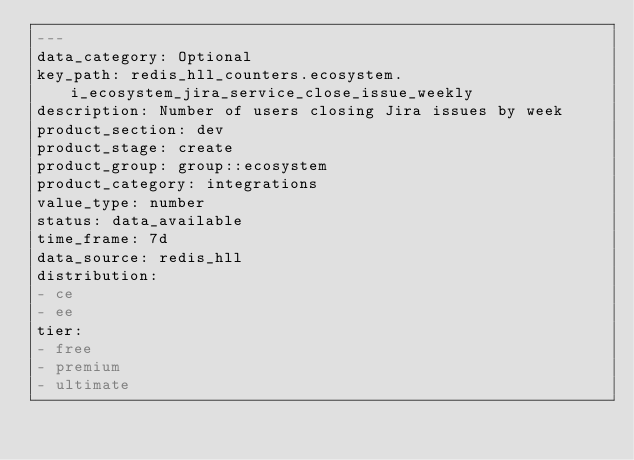<code> <loc_0><loc_0><loc_500><loc_500><_YAML_>---
data_category: Optional
key_path: redis_hll_counters.ecosystem.i_ecosystem_jira_service_close_issue_weekly
description: Number of users closing Jira issues by week
product_section: dev
product_stage: create
product_group: group::ecosystem
product_category: integrations
value_type: number
status: data_available
time_frame: 7d
data_source: redis_hll
distribution:
- ce
- ee
tier:
- free
- premium
- ultimate
</code> 